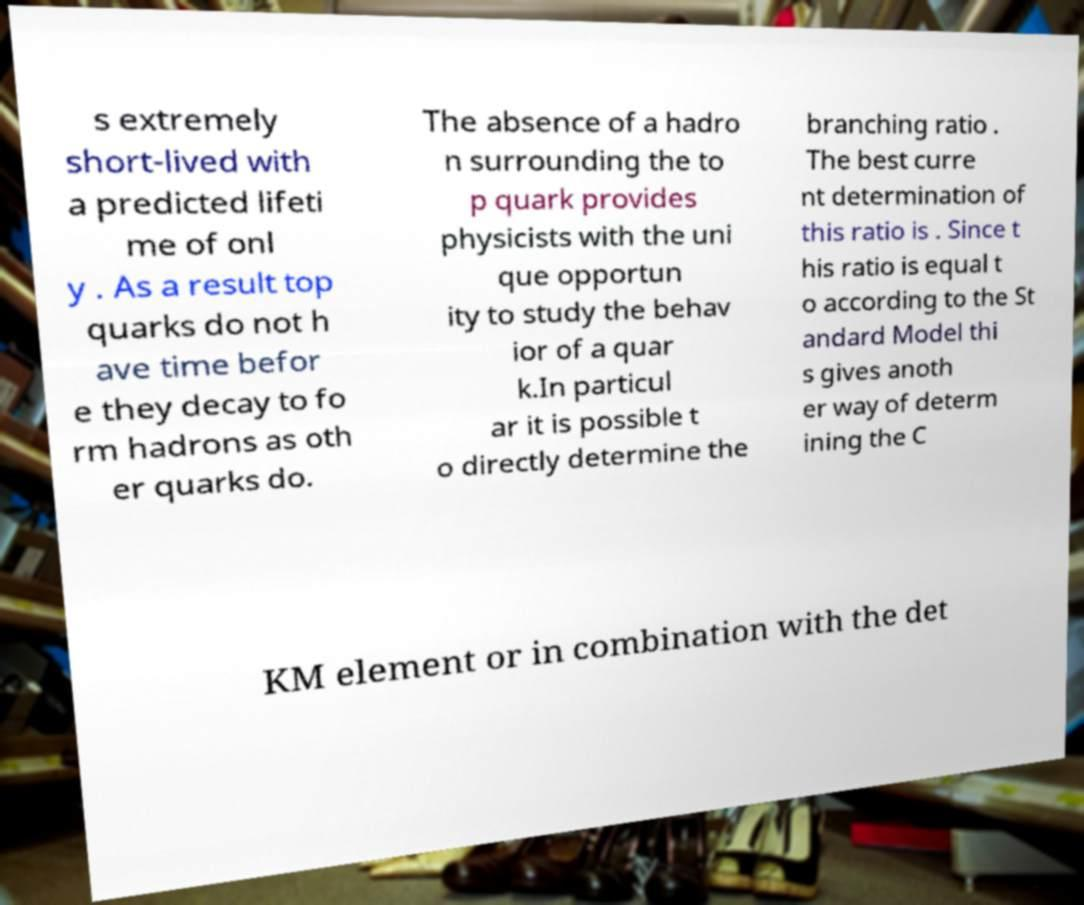Please identify and transcribe the text found in this image. s extremely short-lived with a predicted lifeti me of onl y . As a result top quarks do not h ave time befor e they decay to fo rm hadrons as oth er quarks do. The absence of a hadro n surrounding the to p quark provides physicists with the uni que opportun ity to study the behav ior of a quar k.In particul ar it is possible t o directly determine the branching ratio . The best curre nt determination of this ratio is . Since t his ratio is equal t o according to the St andard Model thi s gives anoth er way of determ ining the C KM element or in combination with the det 